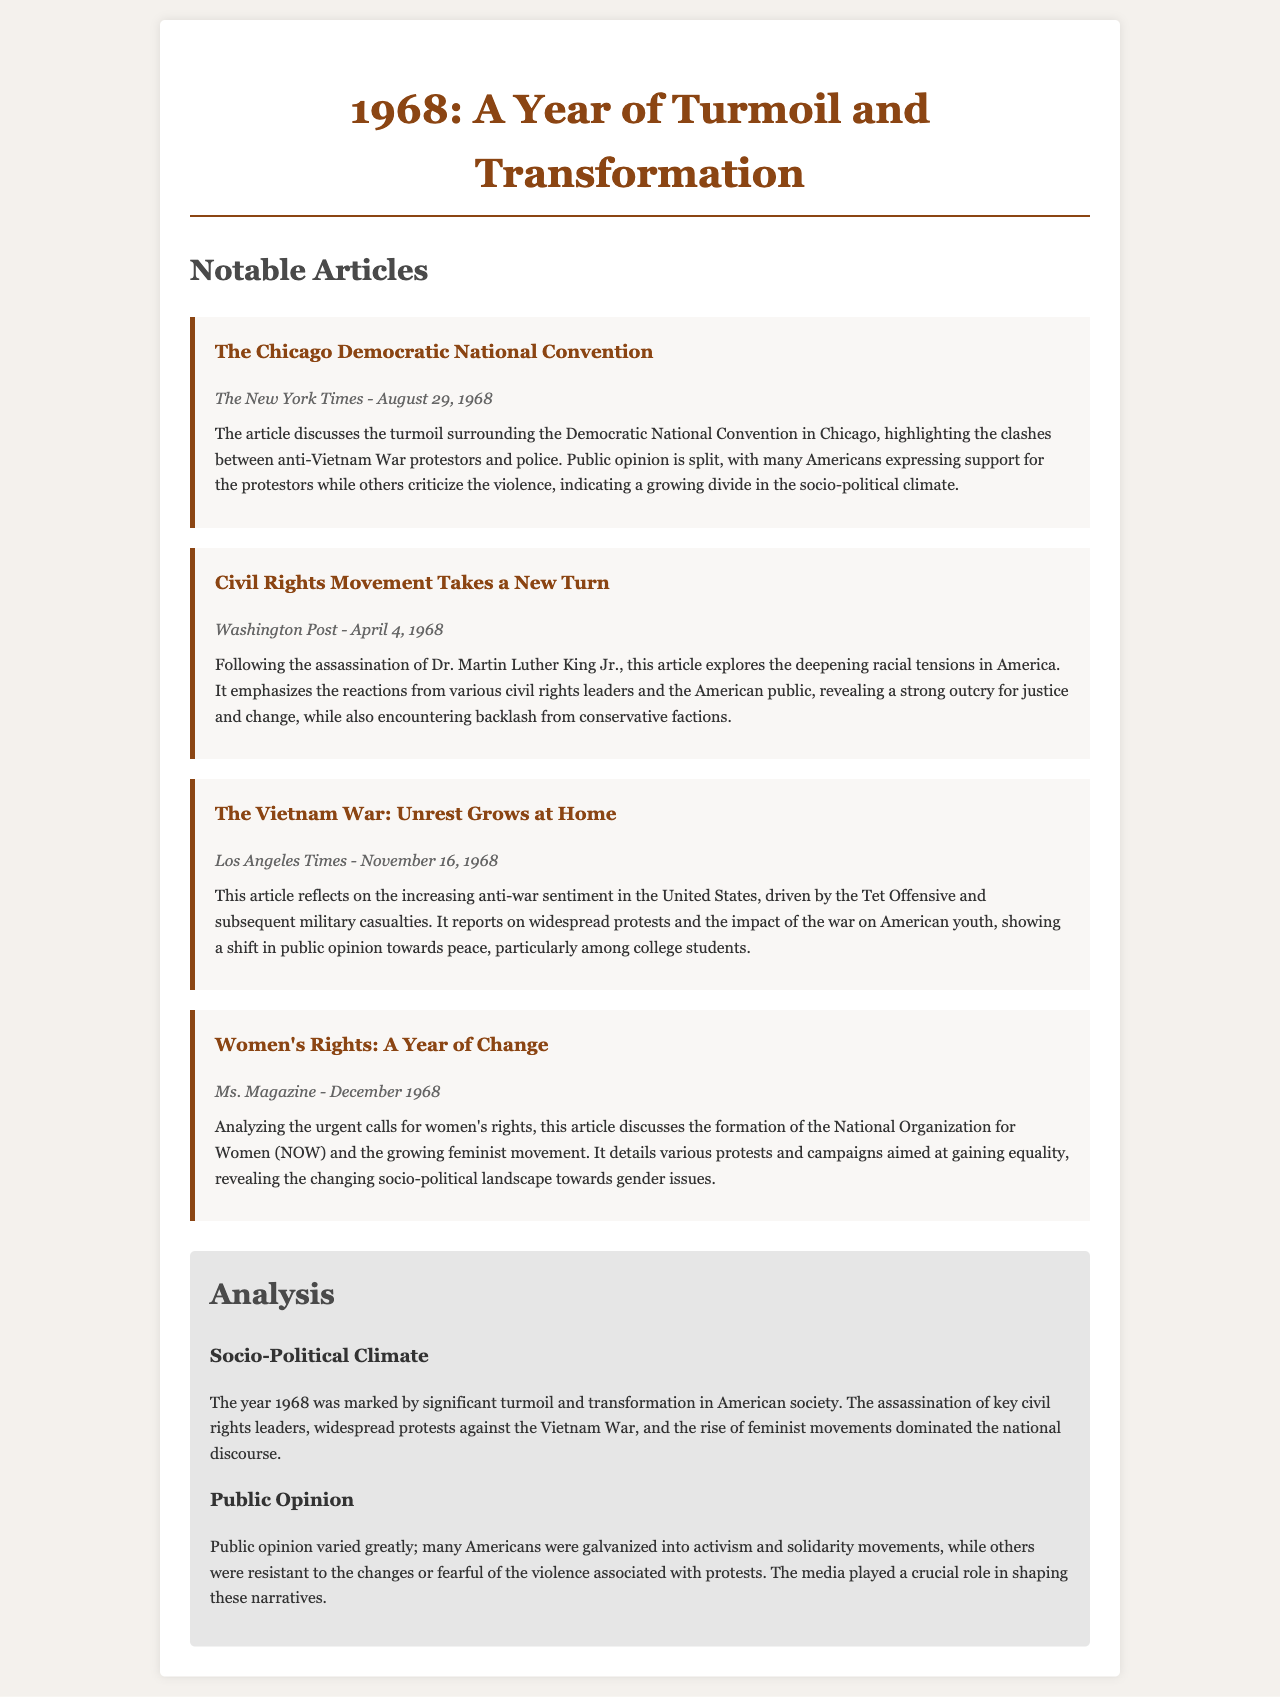What is the title of the document? The title of the document is presented at the top of the rendered document.
Answer: 1968: A Year of Turmoil and Transformation Who wrote the article about the Chicago Democratic National Convention? The author's name can be found in the meta section of the respective article.
Answer: The New York Times What significant event is discussed in the article from April 4, 1968? The significant event is mentioned in the article title and relates to a notable figure's demise.
Answer: Assassination of Dr. Martin Luther King Jr Which organization was formed in 1968 to advocate for women's rights? The document mentions the organization focused on women's rights in the context of socio-political changes.
Answer: National Organization for Women (NOW) What sentiment increased in the US according to the article from November 16, 1968? The article highlights a specific public sentiment growing amongst a demographic due to external circumstances.
Answer: Anti-war sentiment How did public opinion vary according to the analysis section? The analysis describes how public opinion was affected by various socio-political events.
Answer: Galvanized and resistant 